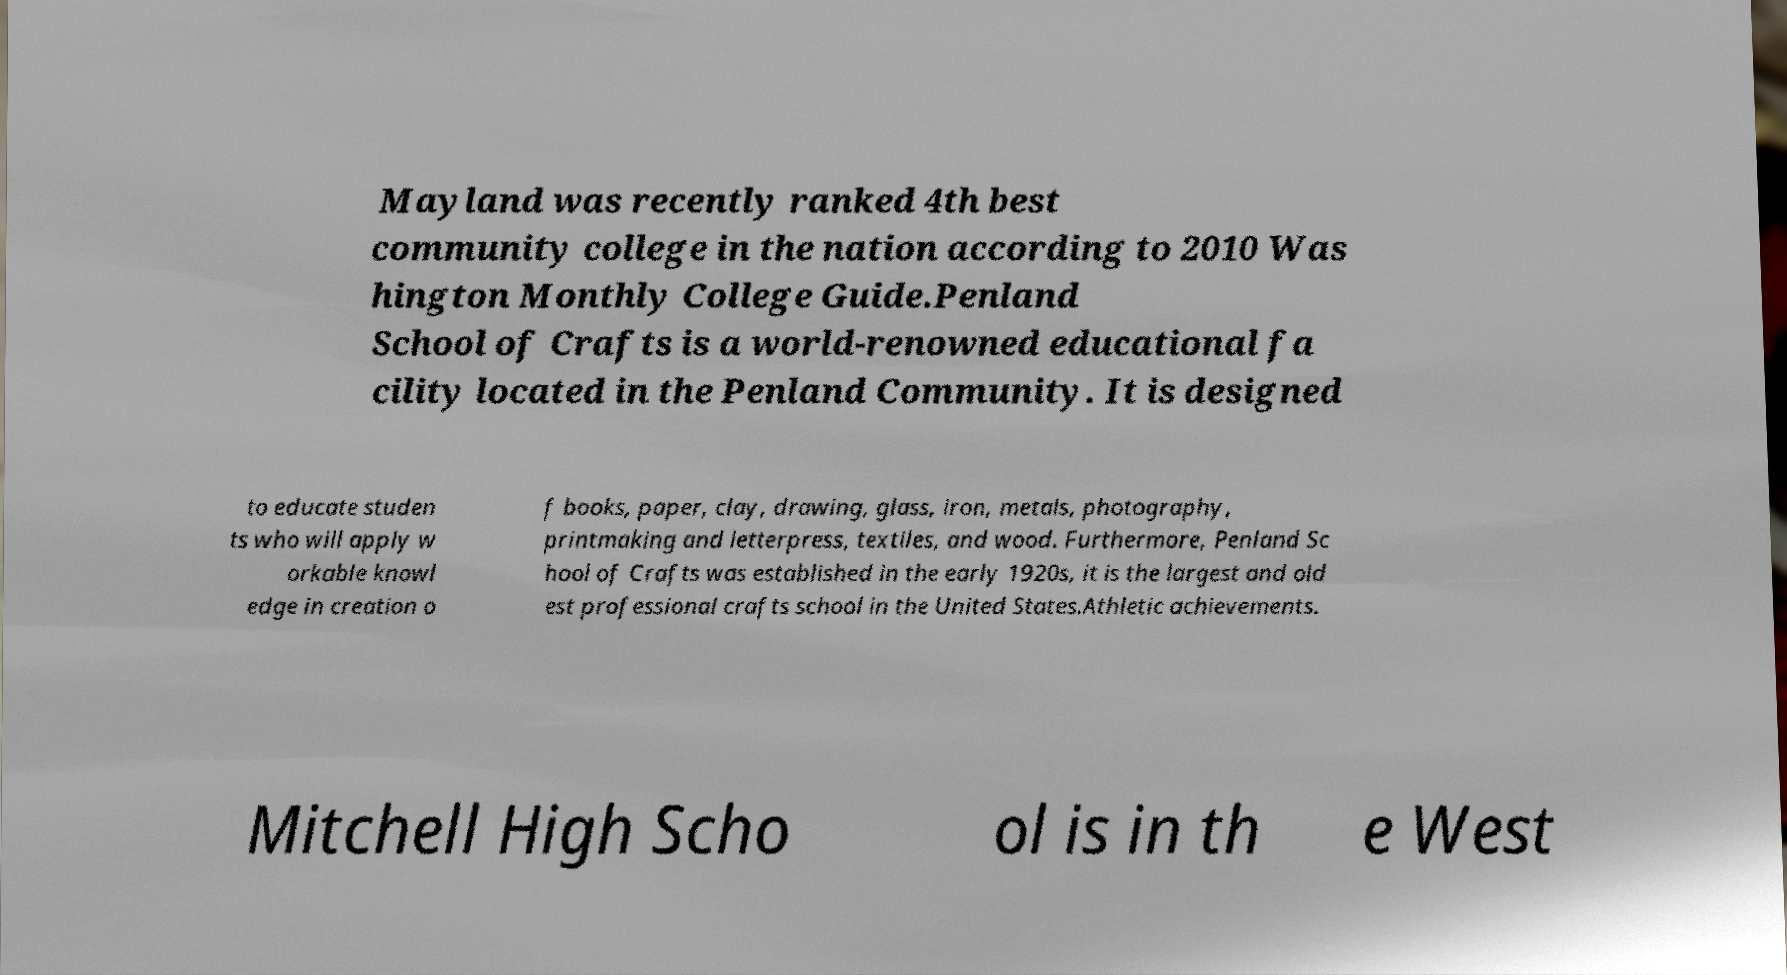There's text embedded in this image that I need extracted. Can you transcribe it verbatim? Mayland was recently ranked 4th best community college in the nation according to 2010 Was hington Monthly College Guide.Penland School of Crafts is a world-renowned educational fa cility located in the Penland Community. It is designed to educate studen ts who will apply w orkable knowl edge in creation o f books, paper, clay, drawing, glass, iron, metals, photography, printmaking and letterpress, textiles, and wood. Furthermore, Penland Sc hool of Crafts was established in the early 1920s, it is the largest and old est professional crafts school in the United States.Athletic achievements. Mitchell High Scho ol is in th e West 